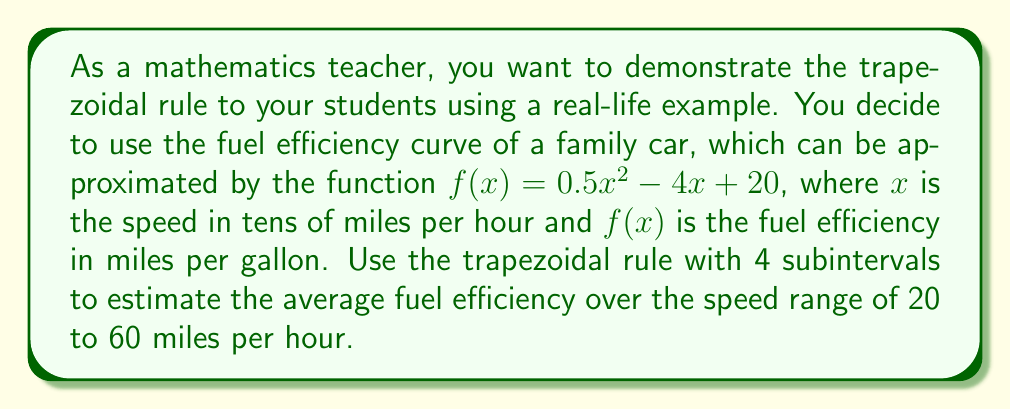Give your solution to this math problem. To solve this problem using the trapezoidal rule, we'll follow these steps:

1) First, we need to set up our integral. We want to find the average value, which is given by:

   $\text{Average} = \frac{1}{b-a}\int_a^b f(x)dx$

   Here, $a = 2$ and $b = 6$ (since we're working in tens of miles per hour).

2) The trapezoidal rule with n subintervals is given by:

   $\int_a^b f(x)dx \approx \frac{b-a}{2n}[f(a) + 2f(x_1) + 2f(x_2) + ... + 2f(x_{n-1}) + f(b)]$

3) We're using 4 subintervals, so $n = 4$. Let's calculate our x-values:

   $x_0 = 2$, $x_1 = 3$, $x_2 = 4$, $x_3 = 5$, $x_4 = 6$

4) Now let's calculate $f(x)$ for each of these x-values:

   $f(2) = 0.5(2)^2 - 4(2) + 20 = 14$
   $f(3) = 0.5(3)^2 - 4(3) + 20 = 12.5$
   $f(4) = 0.5(4)^2 - 4(4) + 20 = 12$
   $f(5) = 0.5(5)^2 - 4(5) + 20 = 12.5$
   $f(6) = 0.5(6)^2 - 4(6) + 20 = 14$

5) Applying the trapezoidal rule:

   $\int_2^6 f(x)dx \approx \frac{6-2}{2(4)}[14 + 2(12.5) + 2(12) + 2(12.5) + 14]$
   $= \frac{1}{2}[14 + 25 + 24 + 25 + 14]$
   $= \frac{1}{2}[102] = 51$

6) To get the average, we divide by $(b-a) = 4$:

   $\text{Average} = \frac{51}{4} = 12.75$

Therefore, the estimated average fuel efficiency over the speed range of 20 to 60 miles per hour is approximately 12.75 miles per gallon.
Answer: 12.75 miles per gallon 